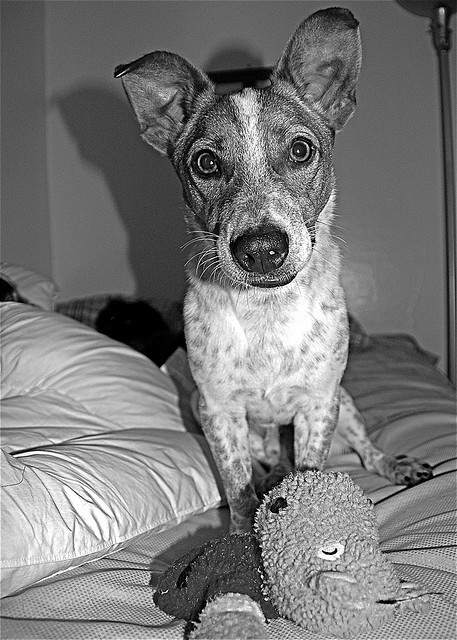Describe the objects in this image and their specific colors. I can see bed in gray, darkgray, lightgray, and black tones, dog in gray, darkgray, lightgray, and black tones, and teddy bear in gray, darkgray, black, and lightgray tones in this image. 